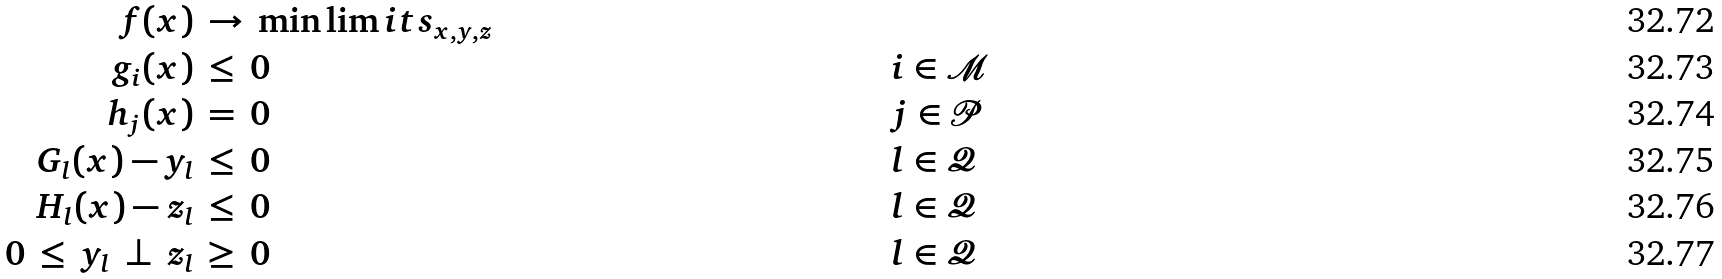<formula> <loc_0><loc_0><loc_500><loc_500>f ( x ) & \, \to \, \min \lim i t s _ { x , y , z } & & & \\ g _ { i } ( x ) & \, \leq \, 0 & \quad & i \in \mathcal { M } & \\ h _ { j } ( x ) & \, = \, 0 & & j \in \mathcal { P } & \\ G _ { l } ( x ) - y _ { l } & \, \leq \, 0 & & l \in \mathcal { Q } & \\ H _ { l } ( x ) - z _ { l } & \, \leq \, 0 & & l \in \mathcal { Q } & \\ 0 \, \leq \, y _ { l } \, \perp \, z _ { l } & \, \geq \, 0 & & l \in \mathcal { Q } &</formula> 